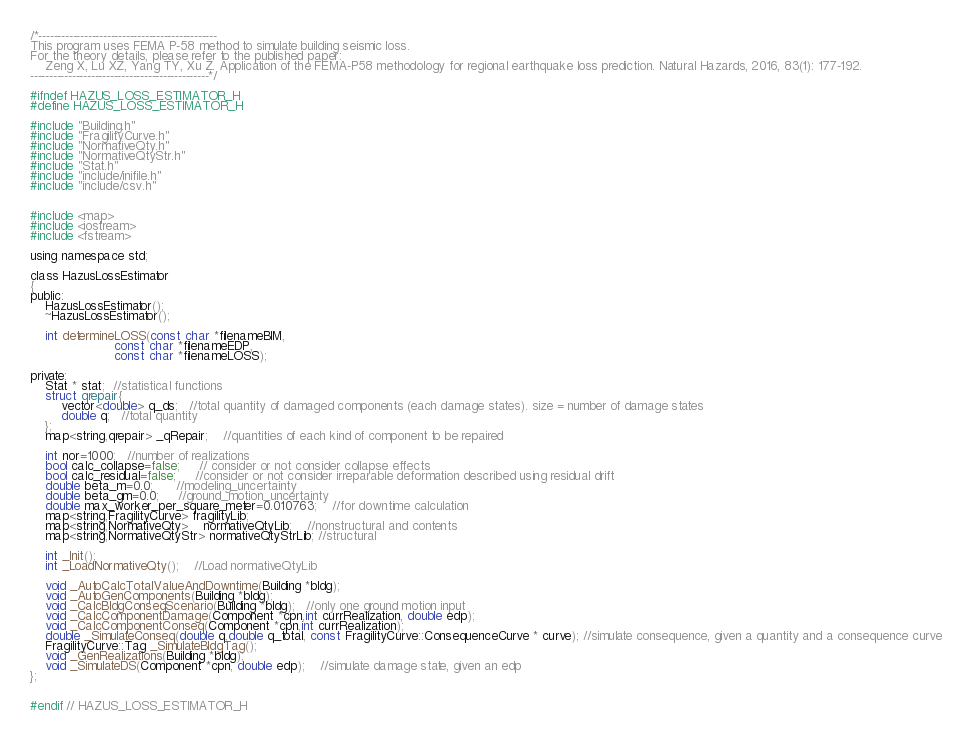Convert code to text. <code><loc_0><loc_0><loc_500><loc_500><_C_>/*-----------------------------------------------
This program uses FEMA P-58 method to simulate building seismic loss.
For the theory details, please refer to the published paper:
    Zeng X, Lu XZ, Yang TY, Xu Z. Application of the FEMA-P58 methodology for regional earthquake loss prediction. Natural Hazards, 2016, 83(1): 177-192.
-----------------------------------------------*/

#ifndef HAZUS_LOSS_ESTIMATOR_H
#define HAZUS_LOSS_ESTIMATOR_H

#include "Building.h"
#include "FragilityCurve.h"
#include "NormativeQty.h"
#include "NormativeQtyStr.h"
#include "Stat.h"
#include "include/inifile.h"
#include "include/csv.h"


#include <map>
#include <iostream>
#include <fstream>

using namespace std;

class HazusLossEstimator
{
public:
    HazusLossEstimator();
    ~HazusLossEstimator();

    int determineLOSS(const char *filenameBIM,
                      const char *filenameEDP,
                      const char *filenameLOSS);

private:
    Stat * stat;  //statistical functions
    struct qrepair{
        vector<double> q_ds;   //total quantity of damaged components (each damage states). size = number of damage states
        double q;   //total quantity
    };
    map<string,qrepair> _qRepair;    //quantities of each kind of component to be repaired

    int nor=1000;   //number of realizations
    bool calc_collapse=false;     // consider or not consider collapse effects
    bool calc_residual=false;     //consider or not consider irreparable deformation described using residual drift
    double beta_m=0.0;      //modeling_uncertainty
    double beta_gm=0.0;     //ground_motion_uncertainty
    double max_worker_per_square_meter=0.010763;    //for downtime calculation
    map<string,FragilityCurve> fragilityLib;
    map<string,NormativeQty>    normativeQtyLib;    //nonstructural and contents
    map<string,NormativeQtyStr> normativeQtyStrLib; //structural

    int _Init();
    int _LoadNormativeQty();    //Load normativeQtyLib

    void _AutoCalcTotalValueAndDowntime(Building *bldg);
    void _AutoGenComponents(Building *bldg);
    void _CalcBldgConseqScenario(Building *bldg);   //only one ground motion input
    void _CalcComponentDamage(Component *cpn,int currRealization, double edp);
    void _CalcComponentConseq(Component *cpn,int currRealization);
    double _SimulateConseq(double q,double q_total, const FragilityCurve::ConsequenceCurve * curve); //simulate consequence, given a quantity and a consequence curve
    FragilityCurve::Tag _SimulateBldgTag();
    void _GenRealizations(Building *bldg);
    void _SimulateDS(Component *cpn, double edp);    //simulate damage state, given an edp
};


#endif // HAZUS_LOSS_ESTIMATOR_H
</code> 